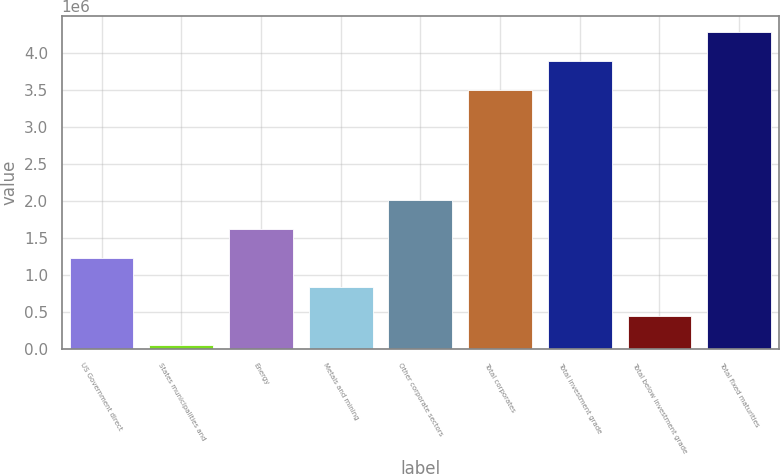Convert chart. <chart><loc_0><loc_0><loc_500><loc_500><bar_chart><fcel>US Government direct<fcel>States municipalities and<fcel>Energy<fcel>Metals and mining<fcel>Other corporate sectors<fcel>Total corporates<fcel>Total investment grade<fcel>Total below investment grade<fcel>Total fixed maturities<nl><fcel>1.23092e+06<fcel>55351<fcel>1.62277e+06<fcel>839062<fcel>2.01463e+06<fcel>3.49892e+06<fcel>3.89077e+06<fcel>447207<fcel>4.28263e+06<nl></chart> 